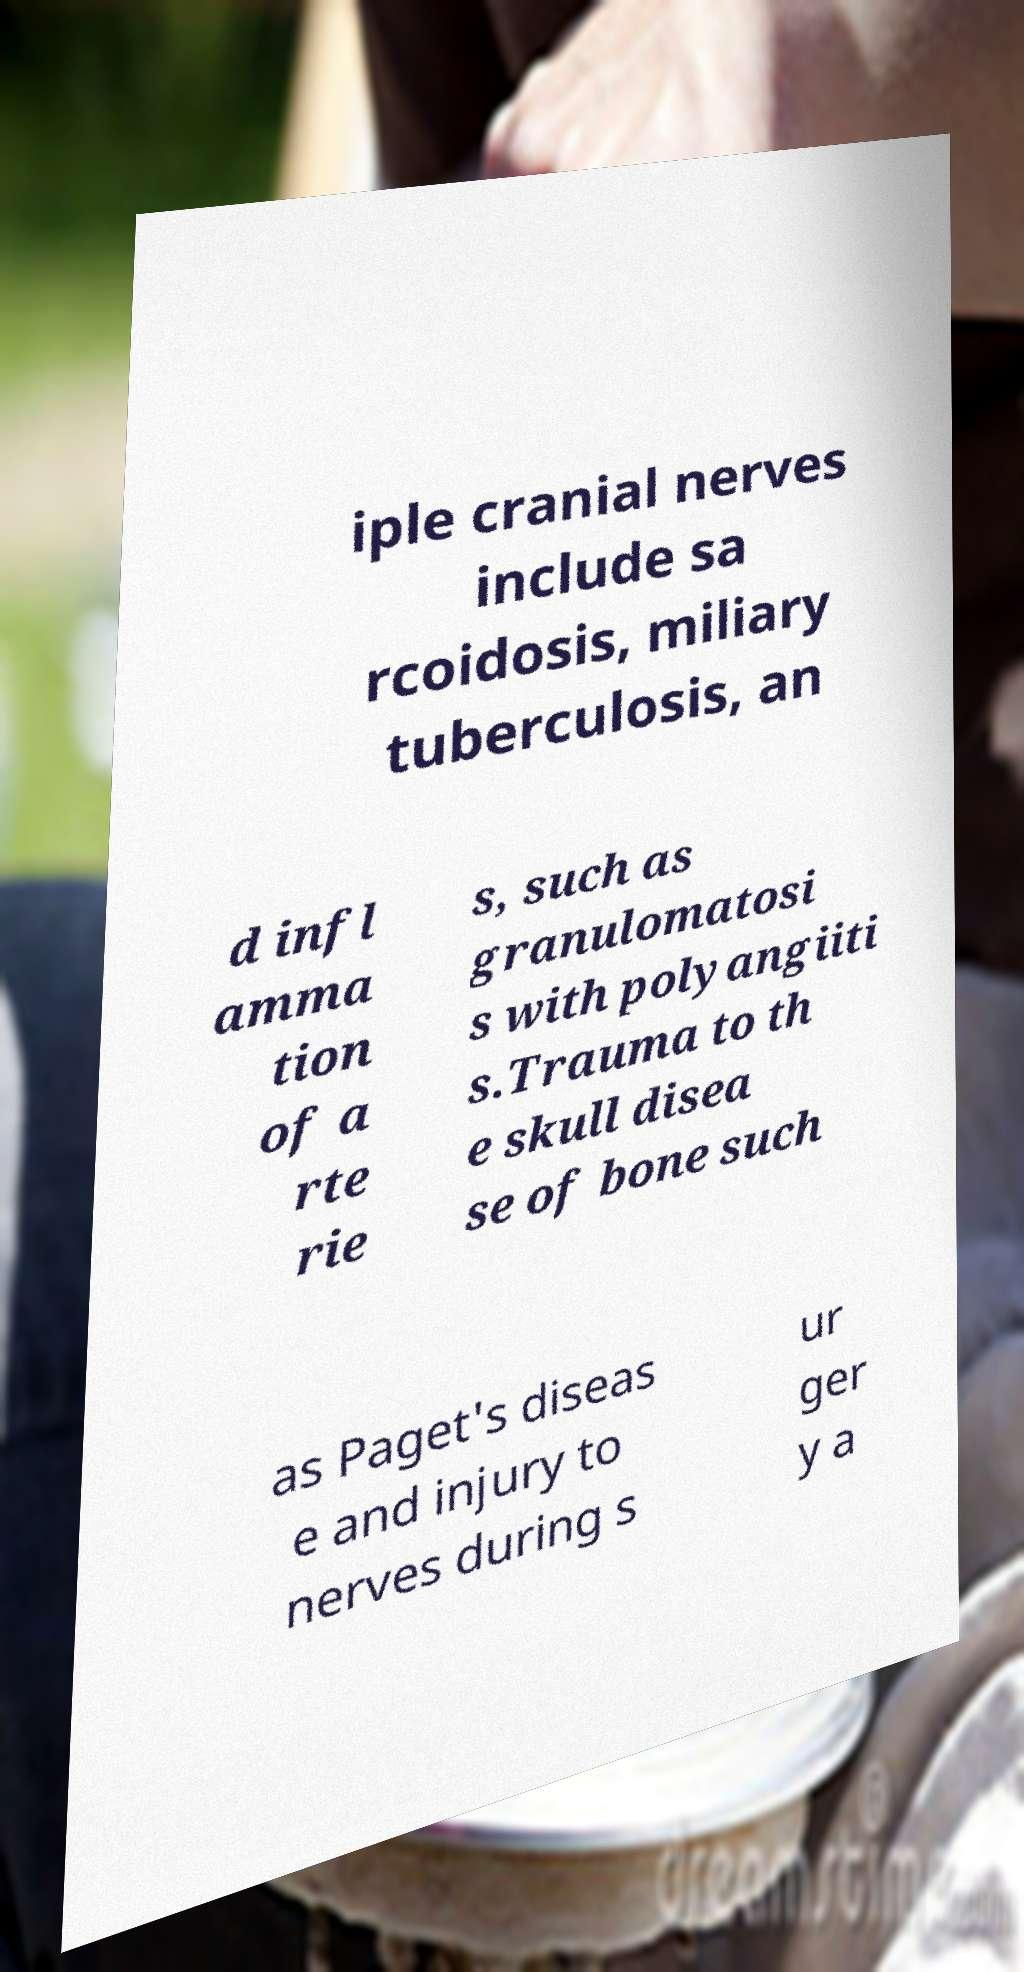Could you assist in decoding the text presented in this image and type it out clearly? iple cranial nerves include sa rcoidosis, miliary tuberculosis, an d infl amma tion of a rte rie s, such as granulomatosi s with polyangiiti s.Trauma to th e skull disea se of bone such as Paget's diseas e and injury to nerves during s ur ger y a 